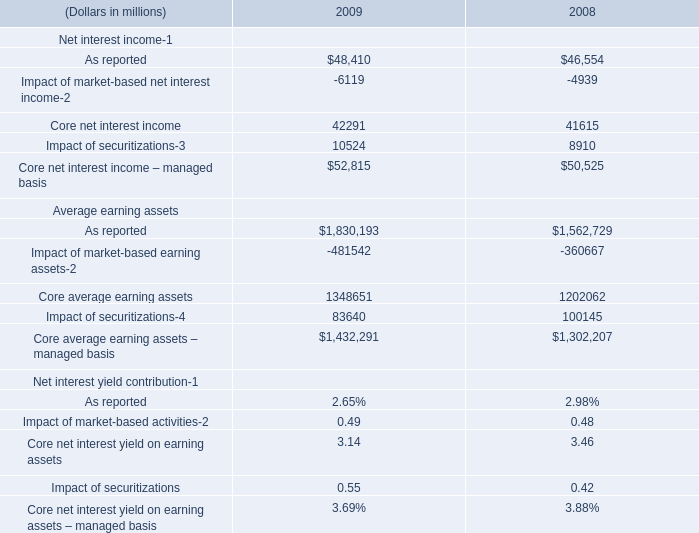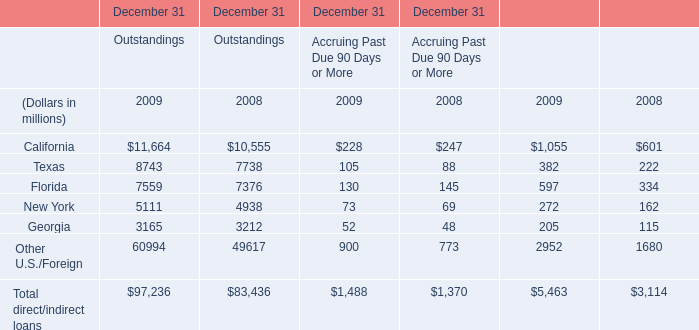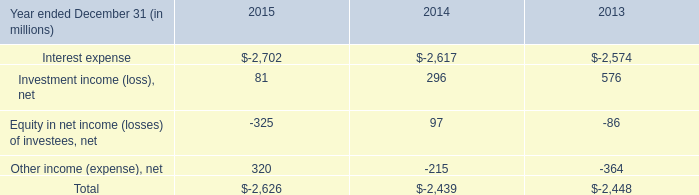What is the average amount of Other U.S./Foreign of December 31 Outstandings 2008, and Core net interest income – managed basis of 2009 ? 
Computations: ((49617.0 + 52815.0) / 2)
Answer: 51216.0. 